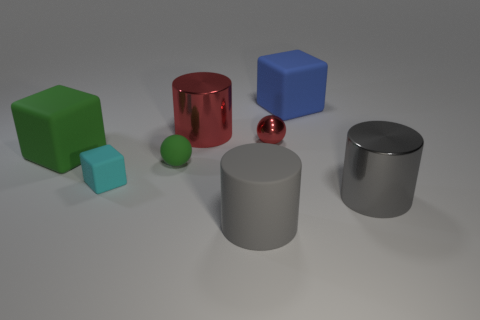Subtract all gray cylinders. How many cylinders are left? 1 Subtract all green spheres. How many spheres are left? 1 Subtract 2 blocks. How many blocks are left? 1 Add 2 tiny things. How many objects exist? 10 Subtract all cylinders. How many objects are left? 5 Subtract all gray cubes. Subtract all red balls. How many cubes are left? 3 Subtract all tiny red shiny things. Subtract all gray metallic objects. How many objects are left? 6 Add 2 cyan cubes. How many cyan cubes are left? 3 Add 8 large green matte objects. How many large green matte objects exist? 9 Subtract 0 yellow balls. How many objects are left? 8 